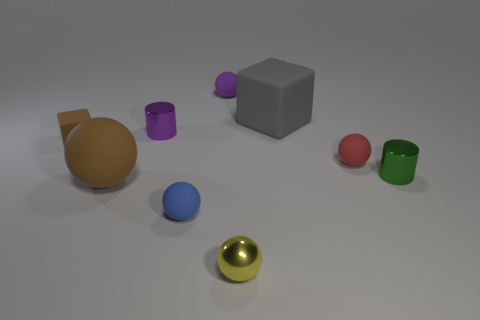Subtract all large brown balls. How many balls are left? 4 Add 1 big purple matte cylinders. How many objects exist? 10 Subtract all purple balls. How many balls are left? 4 Subtract all balls. How many objects are left? 4 Subtract 1 blocks. How many blocks are left? 1 Subtract 0 brown cylinders. How many objects are left? 9 Subtract all gray balls. Subtract all cyan cubes. How many balls are left? 5 Subtract all tiny blue cylinders. Subtract all small purple balls. How many objects are left? 8 Add 8 green cylinders. How many green cylinders are left? 9 Add 7 tiny blue matte blocks. How many tiny blue matte blocks exist? 7 